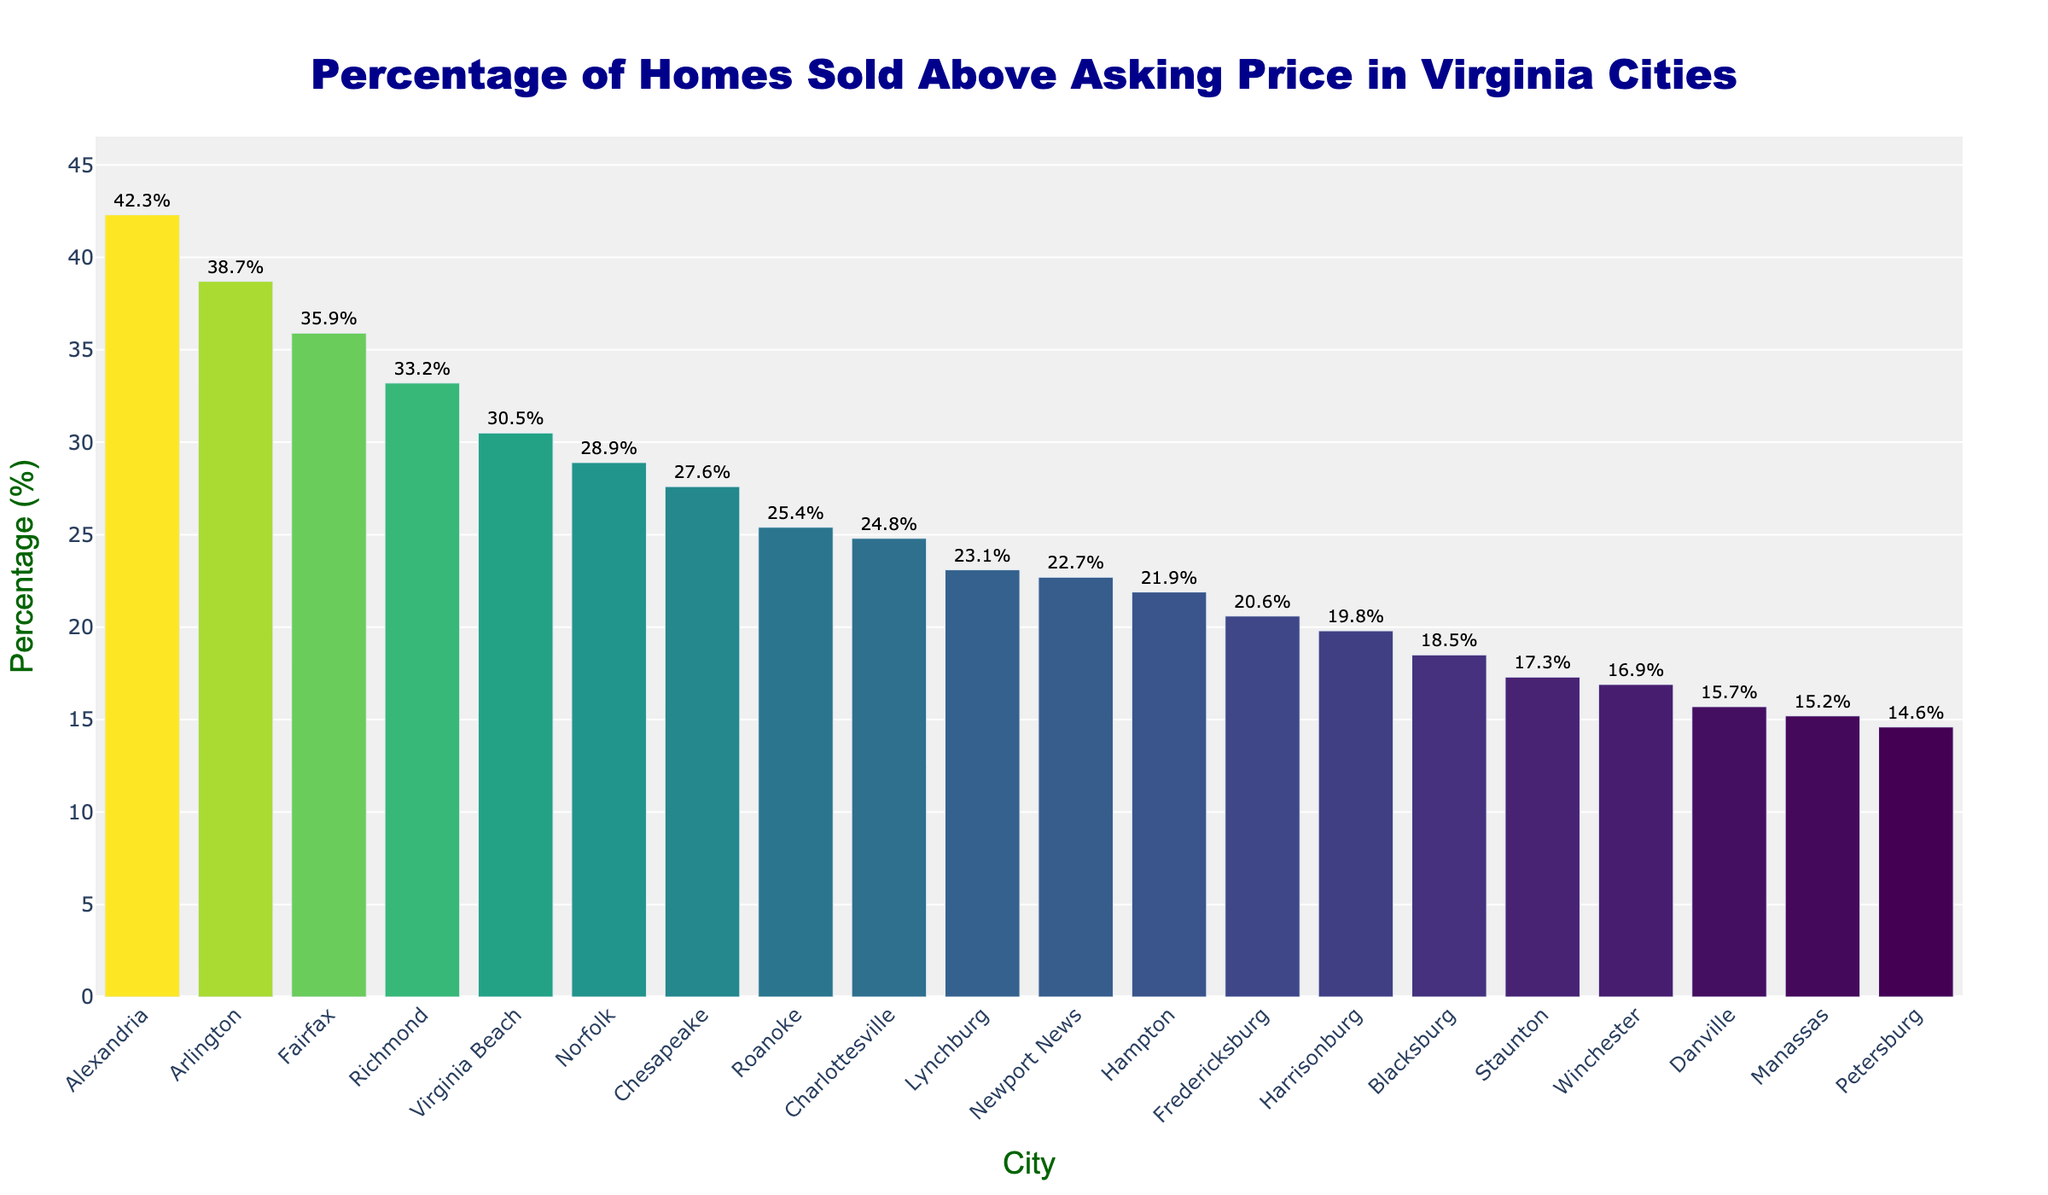What is the city with the highest percentage of homes sold above asking price? The highest bar represents Alexandria, with a percentage of 42.3.
Answer: Alexandria Which city has a higher percentage of homes sold above asking price, Arlington or Virginia Beach? The bar for Arlington is taller with 38.7% compared to Virginia Beach's 30.5%.
Answer: Arlington What is the difference in percentage of homes sold above asking price between the top city and the city at the bottom? Alexandria has 42.3%, and Petersburg has 14.6%. The difference is 42.3 - 14.6 = 27.7.
Answer: 27.7% Which cities have a percentage above 30%? The cities with bars reaching above 30% are Alexandria, Arlington, Fairfax, and Richmond.
Answer: Alexandria, Arlington, Fairfax, Richmond What is the total percentage of homes sold above asking price for the top three cities combined? Adding the percentages of Alexandria (42.3%), Arlington (38.7%), and Fairfax (35.9%) gives 42.3 + 38.7 + 35.9 = 116.9.
Answer: 116.9% What is the median percentage of homes sold above asking price? The cities are sorted in decreasing order. The median lies between Newport News (22.7%) and Hampton (21.9%), so (22.7 + 21.9) / 2 = 22.3.
Answer: 22.3% Which city has the lowest percentage of homes sold above asking price and how much is it? The shortest bar corresponds to Petersburg, with a percentage of 14.6.
Answer: Petersburg, 14.6% Are there more cities with percentages above 25% or below 25%? Counting the bars, there are 8 cities above 25% and 12 cities below 25%.
Answer: Below 25% How many cities have a percentage of homes sold above asking price between 20% and 30% inclusive? The cities falling in this range are Virginia Beach, Norfolk, Chesapeake, Roanoke, Charlottesville, Lynchburg, Newport News, and Hampton, summing up to 8 cities.
Answer: 8 What's the average percentage of homes sold above asking price for all cities? Summing all the percentages: 42.3 + 38.7 + 35.9 + 33.2 + 30.5 + 28.9 + 27.6 + 25.4 + 24.8 + 23.1 + 22.7 + 21.9 + 20.6 + 19.8 + 18.5 + 17.3 + 16.9 + 15.7 + 15.2 + 14.6 = 487.5. Dividing by 20 cities, 487.5 / 20 = 24.375.
Answer: 24.375% 